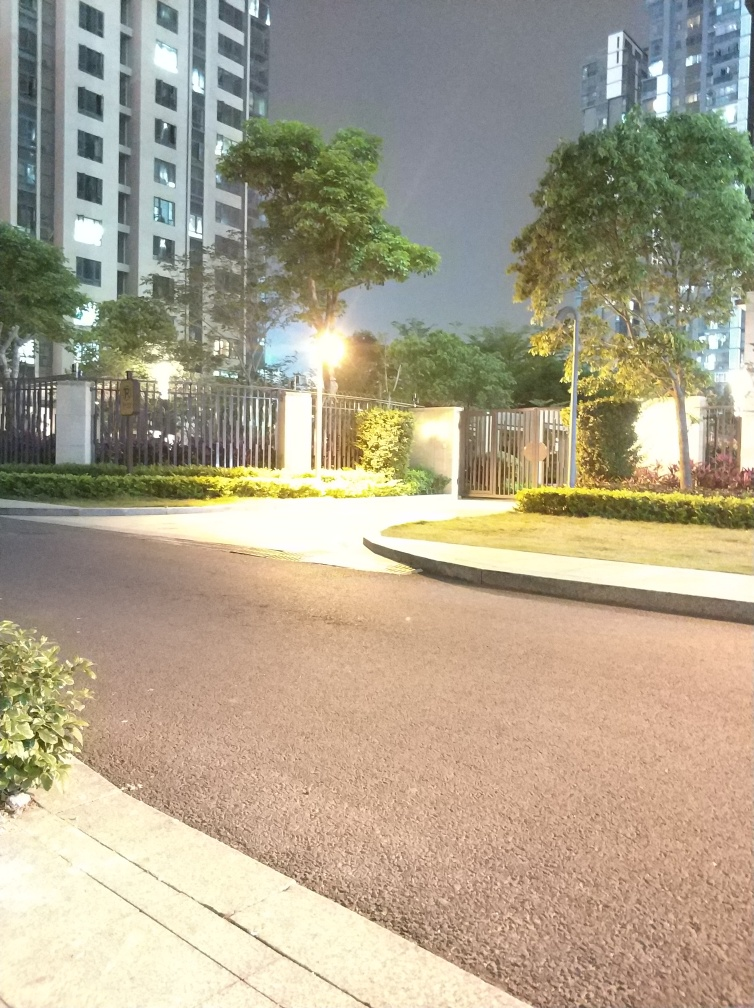Are there any elements in the image that suggest a specific geographical location? Without distinct landmarks or cultural indicators, it's challenging to determine a specific geographical location. However, the modern-style apartment building and structured landscaping might indicate an urban setting in a developed area. If you had to guess, what season do you think it is and why? Given the lack of deciduous trees or visible seasonal decorations, it's difficult to determine the season with certainty. However, the green foliage suggests it's not winter, and the absence of people might imply it is not a particularly warm evening, suggesting spring or fall. 